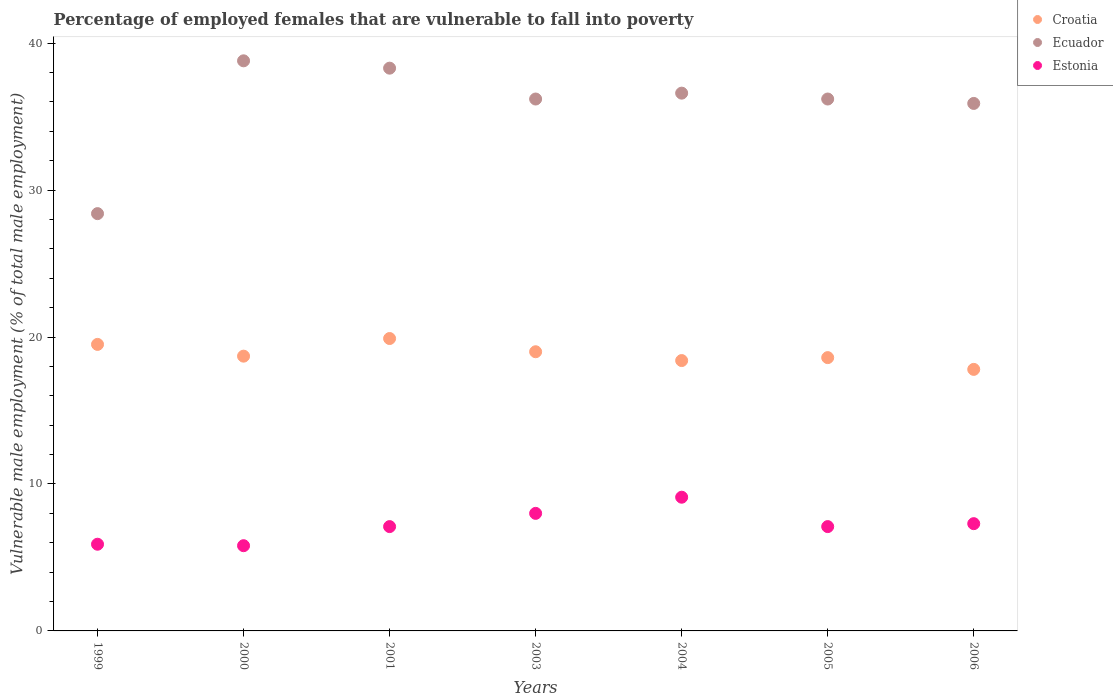How many different coloured dotlines are there?
Ensure brevity in your answer.  3. What is the percentage of employed females who are vulnerable to fall into poverty in Croatia in 2001?
Provide a short and direct response. 19.9. Across all years, what is the maximum percentage of employed females who are vulnerable to fall into poverty in Ecuador?
Offer a terse response. 38.8. Across all years, what is the minimum percentage of employed females who are vulnerable to fall into poverty in Croatia?
Provide a succinct answer. 17.8. In which year was the percentage of employed females who are vulnerable to fall into poverty in Estonia minimum?
Your answer should be very brief. 2000. What is the total percentage of employed females who are vulnerable to fall into poverty in Ecuador in the graph?
Offer a terse response. 250.4. What is the difference between the percentage of employed females who are vulnerable to fall into poverty in Estonia in 2000 and that in 2004?
Provide a succinct answer. -3.3. What is the difference between the percentage of employed females who are vulnerable to fall into poverty in Ecuador in 2003 and the percentage of employed females who are vulnerable to fall into poverty in Croatia in 2005?
Make the answer very short. 17.6. What is the average percentage of employed females who are vulnerable to fall into poverty in Croatia per year?
Your answer should be very brief. 18.84. In the year 2005, what is the difference between the percentage of employed females who are vulnerable to fall into poverty in Croatia and percentage of employed females who are vulnerable to fall into poverty in Estonia?
Your answer should be very brief. 11.5. What is the ratio of the percentage of employed females who are vulnerable to fall into poverty in Ecuador in 2001 to that in 2005?
Your answer should be very brief. 1.06. Is the percentage of employed females who are vulnerable to fall into poverty in Ecuador in 2003 less than that in 2005?
Offer a terse response. No. Is the difference between the percentage of employed females who are vulnerable to fall into poverty in Croatia in 2001 and 2005 greater than the difference between the percentage of employed females who are vulnerable to fall into poverty in Estonia in 2001 and 2005?
Give a very brief answer. Yes. What is the difference between the highest and the second highest percentage of employed females who are vulnerable to fall into poverty in Croatia?
Your answer should be compact. 0.4. What is the difference between the highest and the lowest percentage of employed females who are vulnerable to fall into poverty in Estonia?
Offer a terse response. 3.3. In how many years, is the percentage of employed females who are vulnerable to fall into poverty in Croatia greater than the average percentage of employed females who are vulnerable to fall into poverty in Croatia taken over all years?
Provide a succinct answer. 3. Is the sum of the percentage of employed females who are vulnerable to fall into poverty in Croatia in 2001 and 2006 greater than the maximum percentage of employed females who are vulnerable to fall into poverty in Ecuador across all years?
Ensure brevity in your answer.  No. Is it the case that in every year, the sum of the percentage of employed females who are vulnerable to fall into poverty in Croatia and percentage of employed females who are vulnerable to fall into poverty in Ecuador  is greater than the percentage of employed females who are vulnerable to fall into poverty in Estonia?
Provide a succinct answer. Yes. Does the percentage of employed females who are vulnerable to fall into poverty in Croatia monotonically increase over the years?
Your response must be concise. No. What is the difference between two consecutive major ticks on the Y-axis?
Your answer should be compact. 10. Are the values on the major ticks of Y-axis written in scientific E-notation?
Keep it short and to the point. No. Does the graph contain any zero values?
Your answer should be very brief. No. Does the graph contain grids?
Offer a very short reply. No. Where does the legend appear in the graph?
Ensure brevity in your answer.  Top right. What is the title of the graph?
Your answer should be very brief. Percentage of employed females that are vulnerable to fall into poverty. Does "High income: OECD" appear as one of the legend labels in the graph?
Your response must be concise. No. What is the label or title of the X-axis?
Keep it short and to the point. Years. What is the label or title of the Y-axis?
Ensure brevity in your answer.  Vulnerable male employment (% of total male employment). What is the Vulnerable male employment (% of total male employment) in Croatia in 1999?
Offer a terse response. 19.5. What is the Vulnerable male employment (% of total male employment) of Ecuador in 1999?
Offer a terse response. 28.4. What is the Vulnerable male employment (% of total male employment) of Estonia in 1999?
Your answer should be very brief. 5.9. What is the Vulnerable male employment (% of total male employment) of Croatia in 2000?
Your answer should be very brief. 18.7. What is the Vulnerable male employment (% of total male employment) in Ecuador in 2000?
Make the answer very short. 38.8. What is the Vulnerable male employment (% of total male employment) in Estonia in 2000?
Make the answer very short. 5.8. What is the Vulnerable male employment (% of total male employment) in Croatia in 2001?
Your response must be concise. 19.9. What is the Vulnerable male employment (% of total male employment) in Ecuador in 2001?
Offer a very short reply. 38.3. What is the Vulnerable male employment (% of total male employment) in Estonia in 2001?
Ensure brevity in your answer.  7.1. What is the Vulnerable male employment (% of total male employment) in Ecuador in 2003?
Your answer should be very brief. 36.2. What is the Vulnerable male employment (% of total male employment) of Croatia in 2004?
Ensure brevity in your answer.  18.4. What is the Vulnerable male employment (% of total male employment) of Ecuador in 2004?
Offer a very short reply. 36.6. What is the Vulnerable male employment (% of total male employment) in Estonia in 2004?
Give a very brief answer. 9.1. What is the Vulnerable male employment (% of total male employment) in Croatia in 2005?
Keep it short and to the point. 18.6. What is the Vulnerable male employment (% of total male employment) of Ecuador in 2005?
Give a very brief answer. 36.2. What is the Vulnerable male employment (% of total male employment) of Estonia in 2005?
Make the answer very short. 7.1. What is the Vulnerable male employment (% of total male employment) of Croatia in 2006?
Your response must be concise. 17.8. What is the Vulnerable male employment (% of total male employment) in Ecuador in 2006?
Keep it short and to the point. 35.9. What is the Vulnerable male employment (% of total male employment) of Estonia in 2006?
Offer a terse response. 7.3. Across all years, what is the maximum Vulnerable male employment (% of total male employment) of Croatia?
Provide a succinct answer. 19.9. Across all years, what is the maximum Vulnerable male employment (% of total male employment) of Ecuador?
Provide a short and direct response. 38.8. Across all years, what is the maximum Vulnerable male employment (% of total male employment) of Estonia?
Offer a terse response. 9.1. Across all years, what is the minimum Vulnerable male employment (% of total male employment) in Croatia?
Provide a short and direct response. 17.8. Across all years, what is the minimum Vulnerable male employment (% of total male employment) of Ecuador?
Give a very brief answer. 28.4. Across all years, what is the minimum Vulnerable male employment (% of total male employment) of Estonia?
Provide a succinct answer. 5.8. What is the total Vulnerable male employment (% of total male employment) in Croatia in the graph?
Ensure brevity in your answer.  131.9. What is the total Vulnerable male employment (% of total male employment) in Ecuador in the graph?
Your answer should be very brief. 250.4. What is the total Vulnerable male employment (% of total male employment) in Estonia in the graph?
Keep it short and to the point. 50.3. What is the difference between the Vulnerable male employment (% of total male employment) in Croatia in 1999 and that in 2000?
Provide a short and direct response. 0.8. What is the difference between the Vulnerable male employment (% of total male employment) of Estonia in 1999 and that in 2000?
Your response must be concise. 0.1. What is the difference between the Vulnerable male employment (% of total male employment) in Croatia in 1999 and that in 2001?
Provide a short and direct response. -0.4. What is the difference between the Vulnerable male employment (% of total male employment) of Croatia in 1999 and that in 2003?
Give a very brief answer. 0.5. What is the difference between the Vulnerable male employment (% of total male employment) of Estonia in 1999 and that in 2003?
Ensure brevity in your answer.  -2.1. What is the difference between the Vulnerable male employment (% of total male employment) in Croatia in 1999 and that in 2004?
Provide a short and direct response. 1.1. What is the difference between the Vulnerable male employment (% of total male employment) of Ecuador in 1999 and that in 2004?
Make the answer very short. -8.2. What is the difference between the Vulnerable male employment (% of total male employment) in Estonia in 1999 and that in 2005?
Provide a short and direct response. -1.2. What is the difference between the Vulnerable male employment (% of total male employment) of Croatia in 1999 and that in 2006?
Provide a short and direct response. 1.7. What is the difference between the Vulnerable male employment (% of total male employment) of Estonia in 1999 and that in 2006?
Your answer should be compact. -1.4. What is the difference between the Vulnerable male employment (% of total male employment) in Croatia in 2000 and that in 2001?
Give a very brief answer. -1.2. What is the difference between the Vulnerable male employment (% of total male employment) in Estonia in 2000 and that in 2001?
Ensure brevity in your answer.  -1.3. What is the difference between the Vulnerable male employment (% of total male employment) of Ecuador in 2000 and that in 2003?
Ensure brevity in your answer.  2.6. What is the difference between the Vulnerable male employment (% of total male employment) in Croatia in 2000 and that in 2004?
Ensure brevity in your answer.  0.3. What is the difference between the Vulnerable male employment (% of total male employment) in Ecuador in 2000 and that in 2004?
Offer a terse response. 2.2. What is the difference between the Vulnerable male employment (% of total male employment) in Ecuador in 2000 and that in 2005?
Offer a very short reply. 2.6. What is the difference between the Vulnerable male employment (% of total male employment) in Estonia in 2000 and that in 2005?
Offer a terse response. -1.3. What is the difference between the Vulnerable male employment (% of total male employment) in Ecuador in 2000 and that in 2006?
Ensure brevity in your answer.  2.9. What is the difference between the Vulnerable male employment (% of total male employment) of Estonia in 2000 and that in 2006?
Provide a succinct answer. -1.5. What is the difference between the Vulnerable male employment (% of total male employment) of Ecuador in 2001 and that in 2003?
Keep it short and to the point. 2.1. What is the difference between the Vulnerable male employment (% of total male employment) in Estonia in 2001 and that in 2003?
Make the answer very short. -0.9. What is the difference between the Vulnerable male employment (% of total male employment) of Croatia in 2001 and that in 2005?
Offer a terse response. 1.3. What is the difference between the Vulnerable male employment (% of total male employment) of Croatia in 2001 and that in 2006?
Make the answer very short. 2.1. What is the difference between the Vulnerable male employment (% of total male employment) of Ecuador in 2001 and that in 2006?
Your answer should be compact. 2.4. What is the difference between the Vulnerable male employment (% of total male employment) of Estonia in 2001 and that in 2006?
Offer a terse response. -0.2. What is the difference between the Vulnerable male employment (% of total male employment) in Croatia in 2003 and that in 2004?
Your response must be concise. 0.6. What is the difference between the Vulnerable male employment (% of total male employment) in Ecuador in 2003 and that in 2004?
Provide a short and direct response. -0.4. What is the difference between the Vulnerable male employment (% of total male employment) of Estonia in 2004 and that in 2005?
Your answer should be compact. 2. What is the difference between the Vulnerable male employment (% of total male employment) of Ecuador in 2004 and that in 2006?
Offer a terse response. 0.7. What is the difference between the Vulnerable male employment (% of total male employment) in Croatia in 2005 and that in 2006?
Offer a terse response. 0.8. What is the difference between the Vulnerable male employment (% of total male employment) in Ecuador in 2005 and that in 2006?
Your answer should be compact. 0.3. What is the difference between the Vulnerable male employment (% of total male employment) in Croatia in 1999 and the Vulnerable male employment (% of total male employment) in Ecuador in 2000?
Offer a very short reply. -19.3. What is the difference between the Vulnerable male employment (% of total male employment) of Ecuador in 1999 and the Vulnerable male employment (% of total male employment) of Estonia in 2000?
Offer a very short reply. 22.6. What is the difference between the Vulnerable male employment (% of total male employment) in Croatia in 1999 and the Vulnerable male employment (% of total male employment) in Ecuador in 2001?
Offer a very short reply. -18.8. What is the difference between the Vulnerable male employment (% of total male employment) in Croatia in 1999 and the Vulnerable male employment (% of total male employment) in Estonia in 2001?
Offer a terse response. 12.4. What is the difference between the Vulnerable male employment (% of total male employment) in Ecuador in 1999 and the Vulnerable male employment (% of total male employment) in Estonia in 2001?
Your answer should be compact. 21.3. What is the difference between the Vulnerable male employment (% of total male employment) of Croatia in 1999 and the Vulnerable male employment (% of total male employment) of Ecuador in 2003?
Ensure brevity in your answer.  -16.7. What is the difference between the Vulnerable male employment (% of total male employment) in Croatia in 1999 and the Vulnerable male employment (% of total male employment) in Estonia in 2003?
Keep it short and to the point. 11.5. What is the difference between the Vulnerable male employment (% of total male employment) in Ecuador in 1999 and the Vulnerable male employment (% of total male employment) in Estonia in 2003?
Provide a succinct answer. 20.4. What is the difference between the Vulnerable male employment (% of total male employment) in Croatia in 1999 and the Vulnerable male employment (% of total male employment) in Ecuador in 2004?
Provide a short and direct response. -17.1. What is the difference between the Vulnerable male employment (% of total male employment) of Croatia in 1999 and the Vulnerable male employment (% of total male employment) of Estonia in 2004?
Offer a terse response. 10.4. What is the difference between the Vulnerable male employment (% of total male employment) of Ecuador in 1999 and the Vulnerable male employment (% of total male employment) of Estonia in 2004?
Offer a very short reply. 19.3. What is the difference between the Vulnerable male employment (% of total male employment) in Croatia in 1999 and the Vulnerable male employment (% of total male employment) in Ecuador in 2005?
Give a very brief answer. -16.7. What is the difference between the Vulnerable male employment (% of total male employment) of Ecuador in 1999 and the Vulnerable male employment (% of total male employment) of Estonia in 2005?
Give a very brief answer. 21.3. What is the difference between the Vulnerable male employment (% of total male employment) in Croatia in 1999 and the Vulnerable male employment (% of total male employment) in Ecuador in 2006?
Your answer should be compact. -16.4. What is the difference between the Vulnerable male employment (% of total male employment) of Ecuador in 1999 and the Vulnerable male employment (% of total male employment) of Estonia in 2006?
Your response must be concise. 21.1. What is the difference between the Vulnerable male employment (% of total male employment) in Croatia in 2000 and the Vulnerable male employment (% of total male employment) in Ecuador in 2001?
Provide a succinct answer. -19.6. What is the difference between the Vulnerable male employment (% of total male employment) of Ecuador in 2000 and the Vulnerable male employment (% of total male employment) of Estonia in 2001?
Your answer should be very brief. 31.7. What is the difference between the Vulnerable male employment (% of total male employment) of Croatia in 2000 and the Vulnerable male employment (% of total male employment) of Ecuador in 2003?
Offer a terse response. -17.5. What is the difference between the Vulnerable male employment (% of total male employment) in Croatia in 2000 and the Vulnerable male employment (% of total male employment) in Estonia in 2003?
Keep it short and to the point. 10.7. What is the difference between the Vulnerable male employment (% of total male employment) in Ecuador in 2000 and the Vulnerable male employment (% of total male employment) in Estonia in 2003?
Keep it short and to the point. 30.8. What is the difference between the Vulnerable male employment (% of total male employment) of Croatia in 2000 and the Vulnerable male employment (% of total male employment) of Ecuador in 2004?
Your answer should be compact. -17.9. What is the difference between the Vulnerable male employment (% of total male employment) in Ecuador in 2000 and the Vulnerable male employment (% of total male employment) in Estonia in 2004?
Provide a short and direct response. 29.7. What is the difference between the Vulnerable male employment (% of total male employment) in Croatia in 2000 and the Vulnerable male employment (% of total male employment) in Ecuador in 2005?
Provide a short and direct response. -17.5. What is the difference between the Vulnerable male employment (% of total male employment) in Ecuador in 2000 and the Vulnerable male employment (% of total male employment) in Estonia in 2005?
Your response must be concise. 31.7. What is the difference between the Vulnerable male employment (% of total male employment) of Croatia in 2000 and the Vulnerable male employment (% of total male employment) of Ecuador in 2006?
Give a very brief answer. -17.2. What is the difference between the Vulnerable male employment (% of total male employment) in Ecuador in 2000 and the Vulnerable male employment (% of total male employment) in Estonia in 2006?
Your response must be concise. 31.5. What is the difference between the Vulnerable male employment (% of total male employment) of Croatia in 2001 and the Vulnerable male employment (% of total male employment) of Ecuador in 2003?
Your answer should be very brief. -16.3. What is the difference between the Vulnerable male employment (% of total male employment) of Ecuador in 2001 and the Vulnerable male employment (% of total male employment) of Estonia in 2003?
Offer a very short reply. 30.3. What is the difference between the Vulnerable male employment (% of total male employment) in Croatia in 2001 and the Vulnerable male employment (% of total male employment) in Ecuador in 2004?
Your response must be concise. -16.7. What is the difference between the Vulnerable male employment (% of total male employment) in Croatia in 2001 and the Vulnerable male employment (% of total male employment) in Estonia in 2004?
Ensure brevity in your answer.  10.8. What is the difference between the Vulnerable male employment (% of total male employment) in Ecuador in 2001 and the Vulnerable male employment (% of total male employment) in Estonia in 2004?
Your answer should be compact. 29.2. What is the difference between the Vulnerable male employment (% of total male employment) in Croatia in 2001 and the Vulnerable male employment (% of total male employment) in Ecuador in 2005?
Keep it short and to the point. -16.3. What is the difference between the Vulnerable male employment (% of total male employment) in Ecuador in 2001 and the Vulnerable male employment (% of total male employment) in Estonia in 2005?
Ensure brevity in your answer.  31.2. What is the difference between the Vulnerable male employment (% of total male employment) of Ecuador in 2001 and the Vulnerable male employment (% of total male employment) of Estonia in 2006?
Offer a very short reply. 31. What is the difference between the Vulnerable male employment (% of total male employment) in Croatia in 2003 and the Vulnerable male employment (% of total male employment) in Ecuador in 2004?
Ensure brevity in your answer.  -17.6. What is the difference between the Vulnerable male employment (% of total male employment) of Croatia in 2003 and the Vulnerable male employment (% of total male employment) of Estonia in 2004?
Provide a short and direct response. 9.9. What is the difference between the Vulnerable male employment (% of total male employment) in Ecuador in 2003 and the Vulnerable male employment (% of total male employment) in Estonia in 2004?
Your response must be concise. 27.1. What is the difference between the Vulnerable male employment (% of total male employment) in Croatia in 2003 and the Vulnerable male employment (% of total male employment) in Ecuador in 2005?
Give a very brief answer. -17.2. What is the difference between the Vulnerable male employment (% of total male employment) of Ecuador in 2003 and the Vulnerable male employment (% of total male employment) of Estonia in 2005?
Your answer should be compact. 29.1. What is the difference between the Vulnerable male employment (% of total male employment) in Croatia in 2003 and the Vulnerable male employment (% of total male employment) in Ecuador in 2006?
Make the answer very short. -16.9. What is the difference between the Vulnerable male employment (% of total male employment) of Ecuador in 2003 and the Vulnerable male employment (% of total male employment) of Estonia in 2006?
Give a very brief answer. 28.9. What is the difference between the Vulnerable male employment (% of total male employment) of Croatia in 2004 and the Vulnerable male employment (% of total male employment) of Ecuador in 2005?
Your answer should be compact. -17.8. What is the difference between the Vulnerable male employment (% of total male employment) in Ecuador in 2004 and the Vulnerable male employment (% of total male employment) in Estonia in 2005?
Provide a short and direct response. 29.5. What is the difference between the Vulnerable male employment (% of total male employment) of Croatia in 2004 and the Vulnerable male employment (% of total male employment) of Ecuador in 2006?
Your answer should be compact. -17.5. What is the difference between the Vulnerable male employment (% of total male employment) in Croatia in 2004 and the Vulnerable male employment (% of total male employment) in Estonia in 2006?
Ensure brevity in your answer.  11.1. What is the difference between the Vulnerable male employment (% of total male employment) in Ecuador in 2004 and the Vulnerable male employment (% of total male employment) in Estonia in 2006?
Provide a short and direct response. 29.3. What is the difference between the Vulnerable male employment (% of total male employment) of Croatia in 2005 and the Vulnerable male employment (% of total male employment) of Ecuador in 2006?
Provide a short and direct response. -17.3. What is the difference between the Vulnerable male employment (% of total male employment) of Ecuador in 2005 and the Vulnerable male employment (% of total male employment) of Estonia in 2006?
Your response must be concise. 28.9. What is the average Vulnerable male employment (% of total male employment) in Croatia per year?
Your answer should be very brief. 18.84. What is the average Vulnerable male employment (% of total male employment) of Ecuador per year?
Your response must be concise. 35.77. What is the average Vulnerable male employment (% of total male employment) of Estonia per year?
Provide a short and direct response. 7.19. In the year 1999, what is the difference between the Vulnerable male employment (% of total male employment) in Croatia and Vulnerable male employment (% of total male employment) in Ecuador?
Your answer should be very brief. -8.9. In the year 1999, what is the difference between the Vulnerable male employment (% of total male employment) of Croatia and Vulnerable male employment (% of total male employment) of Estonia?
Offer a terse response. 13.6. In the year 2000, what is the difference between the Vulnerable male employment (% of total male employment) of Croatia and Vulnerable male employment (% of total male employment) of Ecuador?
Provide a succinct answer. -20.1. In the year 2000, what is the difference between the Vulnerable male employment (% of total male employment) in Croatia and Vulnerable male employment (% of total male employment) in Estonia?
Give a very brief answer. 12.9. In the year 2000, what is the difference between the Vulnerable male employment (% of total male employment) in Ecuador and Vulnerable male employment (% of total male employment) in Estonia?
Ensure brevity in your answer.  33. In the year 2001, what is the difference between the Vulnerable male employment (% of total male employment) of Croatia and Vulnerable male employment (% of total male employment) of Ecuador?
Offer a very short reply. -18.4. In the year 2001, what is the difference between the Vulnerable male employment (% of total male employment) in Ecuador and Vulnerable male employment (% of total male employment) in Estonia?
Your response must be concise. 31.2. In the year 2003, what is the difference between the Vulnerable male employment (% of total male employment) in Croatia and Vulnerable male employment (% of total male employment) in Ecuador?
Your answer should be very brief. -17.2. In the year 2003, what is the difference between the Vulnerable male employment (% of total male employment) of Croatia and Vulnerable male employment (% of total male employment) of Estonia?
Your response must be concise. 11. In the year 2003, what is the difference between the Vulnerable male employment (% of total male employment) of Ecuador and Vulnerable male employment (% of total male employment) of Estonia?
Offer a very short reply. 28.2. In the year 2004, what is the difference between the Vulnerable male employment (% of total male employment) in Croatia and Vulnerable male employment (% of total male employment) in Ecuador?
Make the answer very short. -18.2. In the year 2005, what is the difference between the Vulnerable male employment (% of total male employment) in Croatia and Vulnerable male employment (% of total male employment) in Ecuador?
Ensure brevity in your answer.  -17.6. In the year 2005, what is the difference between the Vulnerable male employment (% of total male employment) in Croatia and Vulnerable male employment (% of total male employment) in Estonia?
Keep it short and to the point. 11.5. In the year 2005, what is the difference between the Vulnerable male employment (% of total male employment) of Ecuador and Vulnerable male employment (% of total male employment) of Estonia?
Ensure brevity in your answer.  29.1. In the year 2006, what is the difference between the Vulnerable male employment (% of total male employment) of Croatia and Vulnerable male employment (% of total male employment) of Ecuador?
Provide a short and direct response. -18.1. In the year 2006, what is the difference between the Vulnerable male employment (% of total male employment) of Ecuador and Vulnerable male employment (% of total male employment) of Estonia?
Give a very brief answer. 28.6. What is the ratio of the Vulnerable male employment (% of total male employment) of Croatia in 1999 to that in 2000?
Keep it short and to the point. 1.04. What is the ratio of the Vulnerable male employment (% of total male employment) in Ecuador in 1999 to that in 2000?
Give a very brief answer. 0.73. What is the ratio of the Vulnerable male employment (% of total male employment) of Estonia in 1999 to that in 2000?
Ensure brevity in your answer.  1.02. What is the ratio of the Vulnerable male employment (% of total male employment) of Croatia in 1999 to that in 2001?
Make the answer very short. 0.98. What is the ratio of the Vulnerable male employment (% of total male employment) of Ecuador in 1999 to that in 2001?
Provide a short and direct response. 0.74. What is the ratio of the Vulnerable male employment (% of total male employment) of Estonia in 1999 to that in 2001?
Your answer should be compact. 0.83. What is the ratio of the Vulnerable male employment (% of total male employment) of Croatia in 1999 to that in 2003?
Your answer should be compact. 1.03. What is the ratio of the Vulnerable male employment (% of total male employment) of Ecuador in 1999 to that in 2003?
Your answer should be compact. 0.78. What is the ratio of the Vulnerable male employment (% of total male employment) in Estonia in 1999 to that in 2003?
Make the answer very short. 0.74. What is the ratio of the Vulnerable male employment (% of total male employment) in Croatia in 1999 to that in 2004?
Provide a short and direct response. 1.06. What is the ratio of the Vulnerable male employment (% of total male employment) of Ecuador in 1999 to that in 2004?
Give a very brief answer. 0.78. What is the ratio of the Vulnerable male employment (% of total male employment) in Estonia in 1999 to that in 2004?
Give a very brief answer. 0.65. What is the ratio of the Vulnerable male employment (% of total male employment) of Croatia in 1999 to that in 2005?
Your response must be concise. 1.05. What is the ratio of the Vulnerable male employment (% of total male employment) of Ecuador in 1999 to that in 2005?
Provide a short and direct response. 0.78. What is the ratio of the Vulnerable male employment (% of total male employment) in Estonia in 1999 to that in 2005?
Provide a short and direct response. 0.83. What is the ratio of the Vulnerable male employment (% of total male employment) in Croatia in 1999 to that in 2006?
Your answer should be very brief. 1.1. What is the ratio of the Vulnerable male employment (% of total male employment) of Ecuador in 1999 to that in 2006?
Your response must be concise. 0.79. What is the ratio of the Vulnerable male employment (% of total male employment) in Estonia in 1999 to that in 2006?
Your answer should be very brief. 0.81. What is the ratio of the Vulnerable male employment (% of total male employment) of Croatia in 2000 to that in 2001?
Ensure brevity in your answer.  0.94. What is the ratio of the Vulnerable male employment (% of total male employment) of Ecuador in 2000 to that in 2001?
Give a very brief answer. 1.01. What is the ratio of the Vulnerable male employment (% of total male employment) of Estonia in 2000 to that in 2001?
Offer a very short reply. 0.82. What is the ratio of the Vulnerable male employment (% of total male employment) of Croatia in 2000 to that in 2003?
Give a very brief answer. 0.98. What is the ratio of the Vulnerable male employment (% of total male employment) of Ecuador in 2000 to that in 2003?
Ensure brevity in your answer.  1.07. What is the ratio of the Vulnerable male employment (% of total male employment) in Estonia in 2000 to that in 2003?
Your answer should be compact. 0.72. What is the ratio of the Vulnerable male employment (% of total male employment) of Croatia in 2000 to that in 2004?
Offer a very short reply. 1.02. What is the ratio of the Vulnerable male employment (% of total male employment) in Ecuador in 2000 to that in 2004?
Ensure brevity in your answer.  1.06. What is the ratio of the Vulnerable male employment (% of total male employment) in Estonia in 2000 to that in 2004?
Provide a short and direct response. 0.64. What is the ratio of the Vulnerable male employment (% of total male employment) of Croatia in 2000 to that in 2005?
Your answer should be very brief. 1.01. What is the ratio of the Vulnerable male employment (% of total male employment) in Ecuador in 2000 to that in 2005?
Your answer should be very brief. 1.07. What is the ratio of the Vulnerable male employment (% of total male employment) of Estonia in 2000 to that in 2005?
Keep it short and to the point. 0.82. What is the ratio of the Vulnerable male employment (% of total male employment) in Croatia in 2000 to that in 2006?
Your answer should be compact. 1.05. What is the ratio of the Vulnerable male employment (% of total male employment) in Ecuador in 2000 to that in 2006?
Provide a short and direct response. 1.08. What is the ratio of the Vulnerable male employment (% of total male employment) of Estonia in 2000 to that in 2006?
Your response must be concise. 0.79. What is the ratio of the Vulnerable male employment (% of total male employment) in Croatia in 2001 to that in 2003?
Provide a short and direct response. 1.05. What is the ratio of the Vulnerable male employment (% of total male employment) in Ecuador in 2001 to that in 2003?
Offer a terse response. 1.06. What is the ratio of the Vulnerable male employment (% of total male employment) in Estonia in 2001 to that in 2003?
Give a very brief answer. 0.89. What is the ratio of the Vulnerable male employment (% of total male employment) of Croatia in 2001 to that in 2004?
Offer a very short reply. 1.08. What is the ratio of the Vulnerable male employment (% of total male employment) in Ecuador in 2001 to that in 2004?
Your answer should be very brief. 1.05. What is the ratio of the Vulnerable male employment (% of total male employment) of Estonia in 2001 to that in 2004?
Provide a short and direct response. 0.78. What is the ratio of the Vulnerable male employment (% of total male employment) in Croatia in 2001 to that in 2005?
Provide a short and direct response. 1.07. What is the ratio of the Vulnerable male employment (% of total male employment) in Ecuador in 2001 to that in 2005?
Your response must be concise. 1.06. What is the ratio of the Vulnerable male employment (% of total male employment) in Croatia in 2001 to that in 2006?
Make the answer very short. 1.12. What is the ratio of the Vulnerable male employment (% of total male employment) in Ecuador in 2001 to that in 2006?
Your answer should be very brief. 1.07. What is the ratio of the Vulnerable male employment (% of total male employment) in Estonia in 2001 to that in 2006?
Offer a terse response. 0.97. What is the ratio of the Vulnerable male employment (% of total male employment) of Croatia in 2003 to that in 2004?
Keep it short and to the point. 1.03. What is the ratio of the Vulnerable male employment (% of total male employment) of Ecuador in 2003 to that in 2004?
Give a very brief answer. 0.99. What is the ratio of the Vulnerable male employment (% of total male employment) in Estonia in 2003 to that in 2004?
Give a very brief answer. 0.88. What is the ratio of the Vulnerable male employment (% of total male employment) of Croatia in 2003 to that in 2005?
Your response must be concise. 1.02. What is the ratio of the Vulnerable male employment (% of total male employment) in Estonia in 2003 to that in 2005?
Your answer should be compact. 1.13. What is the ratio of the Vulnerable male employment (% of total male employment) in Croatia in 2003 to that in 2006?
Ensure brevity in your answer.  1.07. What is the ratio of the Vulnerable male employment (% of total male employment) in Ecuador in 2003 to that in 2006?
Offer a very short reply. 1.01. What is the ratio of the Vulnerable male employment (% of total male employment) of Estonia in 2003 to that in 2006?
Your answer should be very brief. 1.1. What is the ratio of the Vulnerable male employment (% of total male employment) in Croatia in 2004 to that in 2005?
Provide a succinct answer. 0.99. What is the ratio of the Vulnerable male employment (% of total male employment) of Estonia in 2004 to that in 2005?
Keep it short and to the point. 1.28. What is the ratio of the Vulnerable male employment (% of total male employment) of Croatia in 2004 to that in 2006?
Ensure brevity in your answer.  1.03. What is the ratio of the Vulnerable male employment (% of total male employment) of Ecuador in 2004 to that in 2006?
Ensure brevity in your answer.  1.02. What is the ratio of the Vulnerable male employment (% of total male employment) in Estonia in 2004 to that in 2006?
Your answer should be very brief. 1.25. What is the ratio of the Vulnerable male employment (% of total male employment) in Croatia in 2005 to that in 2006?
Keep it short and to the point. 1.04. What is the ratio of the Vulnerable male employment (% of total male employment) in Ecuador in 2005 to that in 2006?
Keep it short and to the point. 1.01. What is the ratio of the Vulnerable male employment (% of total male employment) of Estonia in 2005 to that in 2006?
Provide a succinct answer. 0.97. What is the difference between the highest and the second highest Vulnerable male employment (% of total male employment) of Croatia?
Ensure brevity in your answer.  0.4. What is the difference between the highest and the second highest Vulnerable male employment (% of total male employment) in Ecuador?
Your answer should be compact. 0.5. What is the difference between the highest and the lowest Vulnerable male employment (% of total male employment) in Croatia?
Provide a short and direct response. 2.1. What is the difference between the highest and the lowest Vulnerable male employment (% of total male employment) in Estonia?
Give a very brief answer. 3.3. 